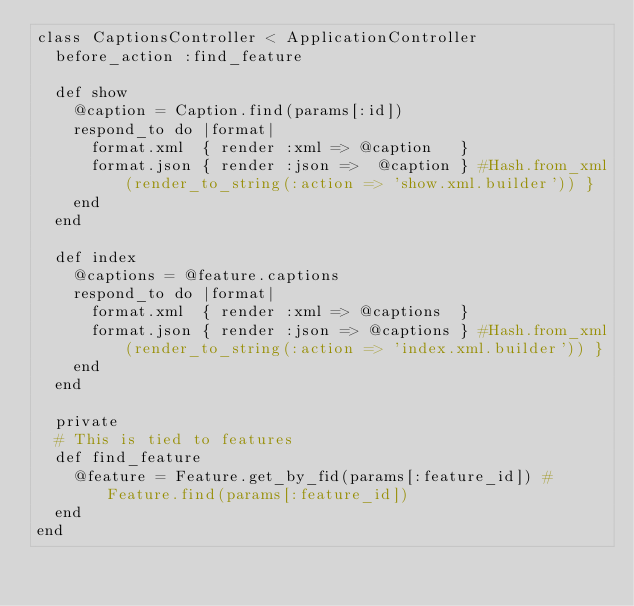<code> <loc_0><loc_0><loc_500><loc_500><_Ruby_>class CaptionsController < ApplicationController
  before_action :find_feature
  
  def show
    @caption = Caption.find(params[:id])
    respond_to do |format|
      format.xml  { render :xml => @caption   }
      format.json { render :json =>  @caption } #Hash.from_xml(render_to_string(:action => 'show.xml.builder')) }
    end
  end

  def index
    @captions = @feature.captions
    respond_to do |format|
      format.xml  { render :xml => @captions  }
      format.json { render :json => @captions } #Hash.from_xml(render_to_string(:action => 'index.xml.builder')) }
    end
  end
  
  private
  # This is tied to features
  def find_feature
    @feature = Feature.get_by_fid(params[:feature_id]) # Feature.find(params[:feature_id])
  end
end
</code> 